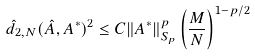<formula> <loc_0><loc_0><loc_500><loc_500>\hat { d } _ { 2 , N } ( \hat { A } , A ^ { * } ) ^ { 2 } \leq C \| A ^ { * } \| _ { S _ { p } } ^ { p } \left ( \frac { M } { N } \right ) ^ { 1 - p / 2 }</formula> 